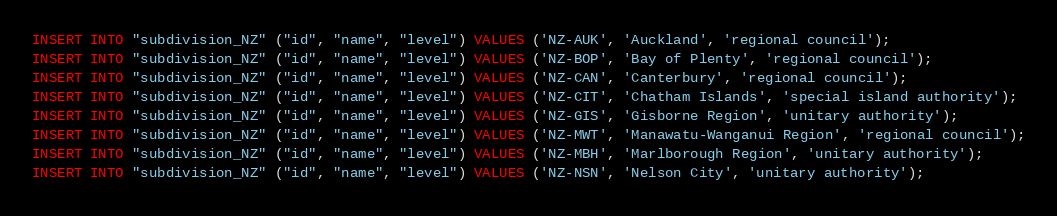<code> <loc_0><loc_0><loc_500><loc_500><_SQL_>INSERT INTO "subdivision_NZ" ("id", "name", "level") VALUES ('NZ-AUK', 'Auckland', 'regional council');
INSERT INTO "subdivision_NZ" ("id", "name", "level") VALUES ('NZ-BOP', 'Bay of Plenty', 'regional council');
INSERT INTO "subdivision_NZ" ("id", "name", "level") VALUES ('NZ-CAN', 'Canterbury', 'regional council');
INSERT INTO "subdivision_NZ" ("id", "name", "level") VALUES ('NZ-CIT', 'Chatham Islands', 'special island authority');
INSERT INTO "subdivision_NZ" ("id", "name", "level") VALUES ('NZ-GIS', 'Gisborne Region', 'unitary authority');
INSERT INTO "subdivision_NZ" ("id", "name", "level") VALUES ('NZ-MWT', 'Manawatu-Wanganui Region', 'regional council');
INSERT INTO "subdivision_NZ" ("id", "name", "level") VALUES ('NZ-MBH', 'Marlborough Region', 'unitary authority');
INSERT INTO "subdivision_NZ" ("id", "name", "level") VALUES ('NZ-NSN', 'Nelson City', 'unitary authority');</code> 